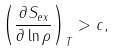<formula> <loc_0><loc_0><loc_500><loc_500>\left ( \frac { \partial S _ { e x } } { \partial \ln \rho } \right ) _ { T } > c ,</formula> 